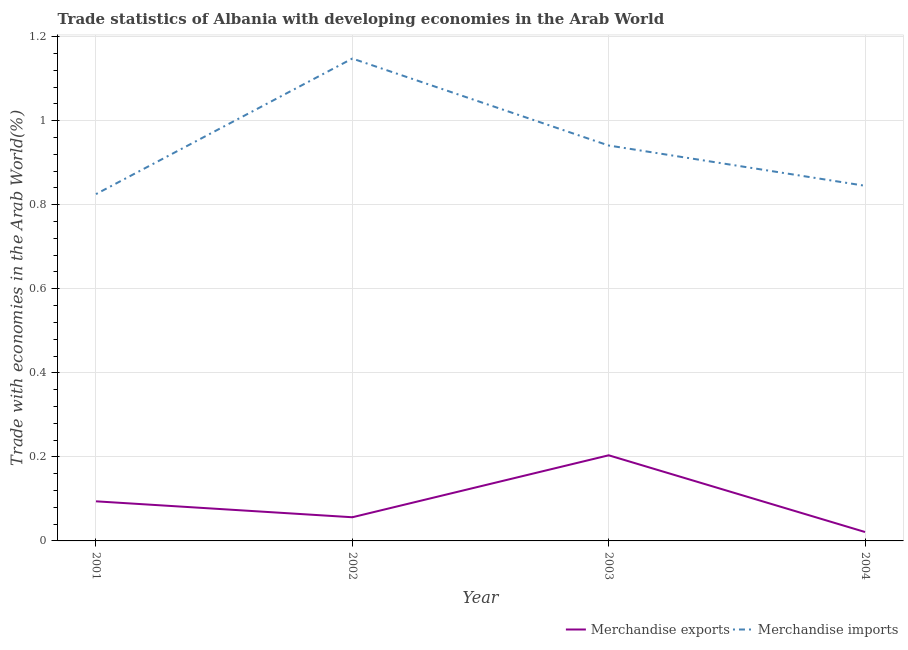How many different coloured lines are there?
Offer a terse response. 2. What is the merchandise exports in 2003?
Keep it short and to the point. 0.2. Across all years, what is the maximum merchandise exports?
Offer a terse response. 0.2. Across all years, what is the minimum merchandise imports?
Make the answer very short. 0.83. In which year was the merchandise exports maximum?
Your answer should be compact. 2003. What is the total merchandise exports in the graph?
Ensure brevity in your answer.  0.38. What is the difference between the merchandise imports in 2001 and that in 2002?
Your response must be concise. -0.32. What is the difference between the merchandise imports in 2003 and the merchandise exports in 2004?
Offer a terse response. 0.92. What is the average merchandise imports per year?
Your response must be concise. 0.94. In the year 2004, what is the difference between the merchandise imports and merchandise exports?
Your answer should be very brief. 0.82. In how many years, is the merchandise imports greater than 0.08 %?
Give a very brief answer. 4. What is the ratio of the merchandise imports in 2003 to that in 2004?
Offer a terse response. 1.11. Is the merchandise imports in 2003 less than that in 2004?
Your answer should be compact. No. What is the difference between the highest and the second highest merchandise exports?
Your response must be concise. 0.11. What is the difference between the highest and the lowest merchandise exports?
Ensure brevity in your answer.  0.18. In how many years, is the merchandise exports greater than the average merchandise exports taken over all years?
Provide a short and direct response. 2. Is the merchandise imports strictly greater than the merchandise exports over the years?
Ensure brevity in your answer.  Yes. Is the merchandise exports strictly less than the merchandise imports over the years?
Offer a very short reply. Yes. How many lines are there?
Keep it short and to the point. 2. What is the difference between two consecutive major ticks on the Y-axis?
Offer a terse response. 0.2. Does the graph contain any zero values?
Offer a terse response. No. How are the legend labels stacked?
Make the answer very short. Horizontal. What is the title of the graph?
Offer a very short reply. Trade statistics of Albania with developing economies in the Arab World. What is the label or title of the X-axis?
Give a very brief answer. Year. What is the label or title of the Y-axis?
Make the answer very short. Trade with economies in the Arab World(%). What is the Trade with economies in the Arab World(%) in Merchandise exports in 2001?
Offer a terse response. 0.09. What is the Trade with economies in the Arab World(%) in Merchandise imports in 2001?
Make the answer very short. 0.83. What is the Trade with economies in the Arab World(%) in Merchandise exports in 2002?
Your answer should be compact. 0.06. What is the Trade with economies in the Arab World(%) of Merchandise imports in 2002?
Provide a succinct answer. 1.15. What is the Trade with economies in the Arab World(%) in Merchandise exports in 2003?
Ensure brevity in your answer.  0.2. What is the Trade with economies in the Arab World(%) of Merchandise imports in 2003?
Give a very brief answer. 0.94. What is the Trade with economies in the Arab World(%) of Merchandise exports in 2004?
Make the answer very short. 0.02. What is the Trade with economies in the Arab World(%) of Merchandise imports in 2004?
Ensure brevity in your answer.  0.85. Across all years, what is the maximum Trade with economies in the Arab World(%) in Merchandise exports?
Your answer should be compact. 0.2. Across all years, what is the maximum Trade with economies in the Arab World(%) in Merchandise imports?
Keep it short and to the point. 1.15. Across all years, what is the minimum Trade with economies in the Arab World(%) of Merchandise exports?
Your response must be concise. 0.02. Across all years, what is the minimum Trade with economies in the Arab World(%) in Merchandise imports?
Offer a very short reply. 0.83. What is the total Trade with economies in the Arab World(%) of Merchandise exports in the graph?
Give a very brief answer. 0.38. What is the total Trade with economies in the Arab World(%) in Merchandise imports in the graph?
Give a very brief answer. 3.76. What is the difference between the Trade with economies in the Arab World(%) in Merchandise exports in 2001 and that in 2002?
Keep it short and to the point. 0.04. What is the difference between the Trade with economies in the Arab World(%) in Merchandise imports in 2001 and that in 2002?
Your response must be concise. -0.32. What is the difference between the Trade with economies in the Arab World(%) of Merchandise exports in 2001 and that in 2003?
Offer a terse response. -0.11. What is the difference between the Trade with economies in the Arab World(%) of Merchandise imports in 2001 and that in 2003?
Your answer should be very brief. -0.12. What is the difference between the Trade with economies in the Arab World(%) of Merchandise exports in 2001 and that in 2004?
Give a very brief answer. 0.07. What is the difference between the Trade with economies in the Arab World(%) in Merchandise imports in 2001 and that in 2004?
Make the answer very short. -0.02. What is the difference between the Trade with economies in the Arab World(%) in Merchandise exports in 2002 and that in 2003?
Provide a succinct answer. -0.15. What is the difference between the Trade with economies in the Arab World(%) in Merchandise imports in 2002 and that in 2003?
Your answer should be compact. 0.21. What is the difference between the Trade with economies in the Arab World(%) in Merchandise exports in 2002 and that in 2004?
Your answer should be compact. 0.04. What is the difference between the Trade with economies in the Arab World(%) in Merchandise imports in 2002 and that in 2004?
Offer a very short reply. 0.3. What is the difference between the Trade with economies in the Arab World(%) of Merchandise exports in 2003 and that in 2004?
Give a very brief answer. 0.18. What is the difference between the Trade with economies in the Arab World(%) in Merchandise imports in 2003 and that in 2004?
Your answer should be compact. 0.1. What is the difference between the Trade with economies in the Arab World(%) of Merchandise exports in 2001 and the Trade with economies in the Arab World(%) of Merchandise imports in 2002?
Ensure brevity in your answer.  -1.05. What is the difference between the Trade with economies in the Arab World(%) in Merchandise exports in 2001 and the Trade with economies in the Arab World(%) in Merchandise imports in 2003?
Provide a short and direct response. -0.85. What is the difference between the Trade with economies in the Arab World(%) of Merchandise exports in 2001 and the Trade with economies in the Arab World(%) of Merchandise imports in 2004?
Offer a very short reply. -0.75. What is the difference between the Trade with economies in the Arab World(%) of Merchandise exports in 2002 and the Trade with economies in the Arab World(%) of Merchandise imports in 2003?
Ensure brevity in your answer.  -0.88. What is the difference between the Trade with economies in the Arab World(%) in Merchandise exports in 2002 and the Trade with economies in the Arab World(%) in Merchandise imports in 2004?
Your answer should be compact. -0.79. What is the difference between the Trade with economies in the Arab World(%) of Merchandise exports in 2003 and the Trade with economies in the Arab World(%) of Merchandise imports in 2004?
Make the answer very short. -0.64. What is the average Trade with economies in the Arab World(%) in Merchandise exports per year?
Provide a short and direct response. 0.09. What is the average Trade with economies in the Arab World(%) in Merchandise imports per year?
Offer a very short reply. 0.94. In the year 2001, what is the difference between the Trade with economies in the Arab World(%) of Merchandise exports and Trade with economies in the Arab World(%) of Merchandise imports?
Make the answer very short. -0.73. In the year 2002, what is the difference between the Trade with economies in the Arab World(%) of Merchandise exports and Trade with economies in the Arab World(%) of Merchandise imports?
Your answer should be compact. -1.09. In the year 2003, what is the difference between the Trade with economies in the Arab World(%) in Merchandise exports and Trade with economies in the Arab World(%) in Merchandise imports?
Keep it short and to the point. -0.74. In the year 2004, what is the difference between the Trade with economies in the Arab World(%) in Merchandise exports and Trade with economies in the Arab World(%) in Merchandise imports?
Provide a succinct answer. -0.82. What is the ratio of the Trade with economies in the Arab World(%) of Merchandise exports in 2001 to that in 2002?
Your answer should be very brief. 1.67. What is the ratio of the Trade with economies in the Arab World(%) in Merchandise imports in 2001 to that in 2002?
Offer a terse response. 0.72. What is the ratio of the Trade with economies in the Arab World(%) in Merchandise exports in 2001 to that in 2003?
Your answer should be compact. 0.46. What is the ratio of the Trade with economies in the Arab World(%) in Merchandise imports in 2001 to that in 2003?
Offer a terse response. 0.88. What is the ratio of the Trade with economies in the Arab World(%) in Merchandise exports in 2001 to that in 2004?
Make the answer very short. 4.44. What is the ratio of the Trade with economies in the Arab World(%) of Merchandise imports in 2001 to that in 2004?
Your answer should be compact. 0.98. What is the ratio of the Trade with economies in the Arab World(%) of Merchandise exports in 2002 to that in 2003?
Give a very brief answer. 0.28. What is the ratio of the Trade with economies in the Arab World(%) in Merchandise imports in 2002 to that in 2003?
Make the answer very short. 1.22. What is the ratio of the Trade with economies in the Arab World(%) of Merchandise exports in 2002 to that in 2004?
Ensure brevity in your answer.  2.66. What is the ratio of the Trade with economies in the Arab World(%) of Merchandise imports in 2002 to that in 2004?
Keep it short and to the point. 1.36. What is the ratio of the Trade with economies in the Arab World(%) in Merchandise exports in 2003 to that in 2004?
Your response must be concise. 9.61. What is the ratio of the Trade with economies in the Arab World(%) in Merchandise imports in 2003 to that in 2004?
Give a very brief answer. 1.11. What is the difference between the highest and the second highest Trade with economies in the Arab World(%) of Merchandise exports?
Ensure brevity in your answer.  0.11. What is the difference between the highest and the second highest Trade with economies in the Arab World(%) in Merchandise imports?
Provide a succinct answer. 0.21. What is the difference between the highest and the lowest Trade with economies in the Arab World(%) in Merchandise exports?
Make the answer very short. 0.18. What is the difference between the highest and the lowest Trade with economies in the Arab World(%) of Merchandise imports?
Make the answer very short. 0.32. 